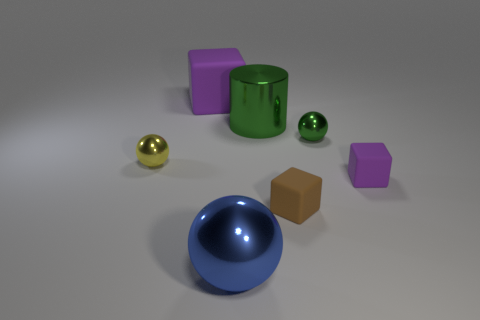Add 3 small metallic balls. How many objects exist? 10 Subtract all balls. How many objects are left? 4 Subtract all matte blocks. Subtract all big balls. How many objects are left? 3 Add 2 large blue things. How many large blue things are left? 3 Add 3 matte things. How many matte things exist? 6 Subtract 0 green cubes. How many objects are left? 7 